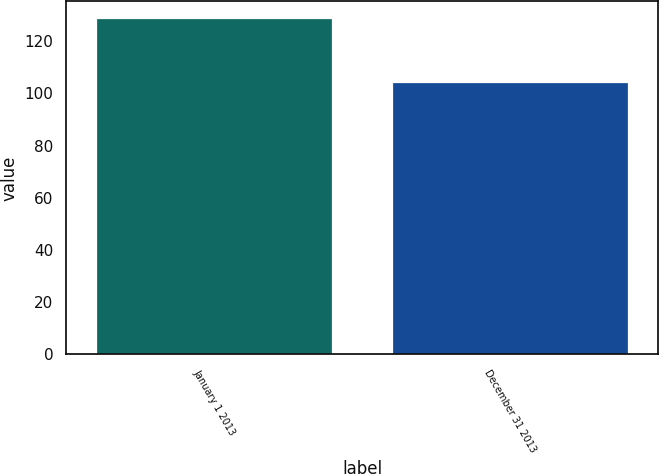Convert chart to OTSL. <chart><loc_0><loc_0><loc_500><loc_500><bar_chart><fcel>January 1 2013<fcel>December 31 2013<nl><fcel>128.8<fcel>104.3<nl></chart> 